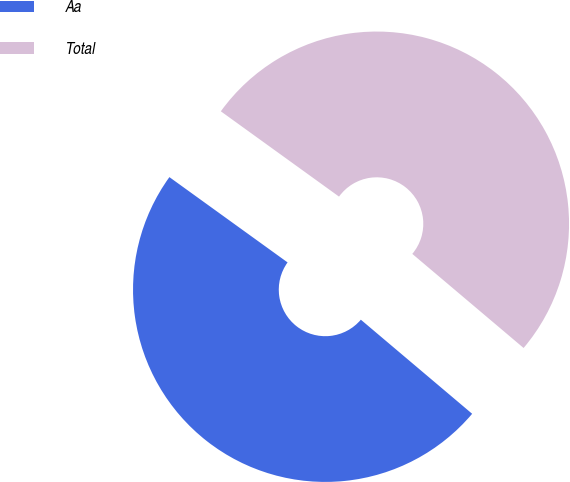Convert chart. <chart><loc_0><loc_0><loc_500><loc_500><pie_chart><fcel>Aa<fcel>Total<nl><fcel>48.78%<fcel>51.22%<nl></chart> 